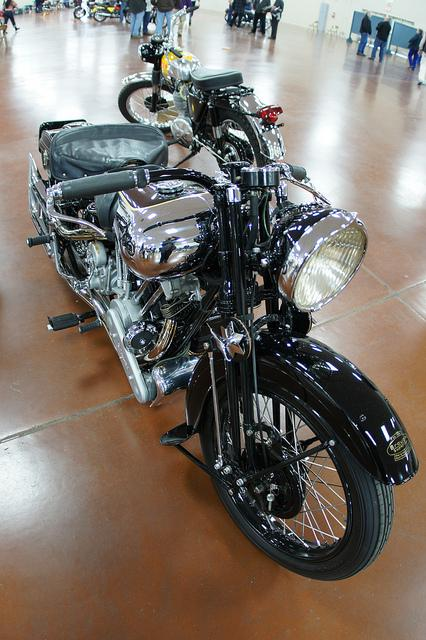What is the large glass object on the bike called? Please explain your reasoning. headlight. The headlight is the large piece of glass. 